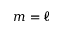<formula> <loc_0><loc_0><loc_500><loc_500>m = \ell</formula> 